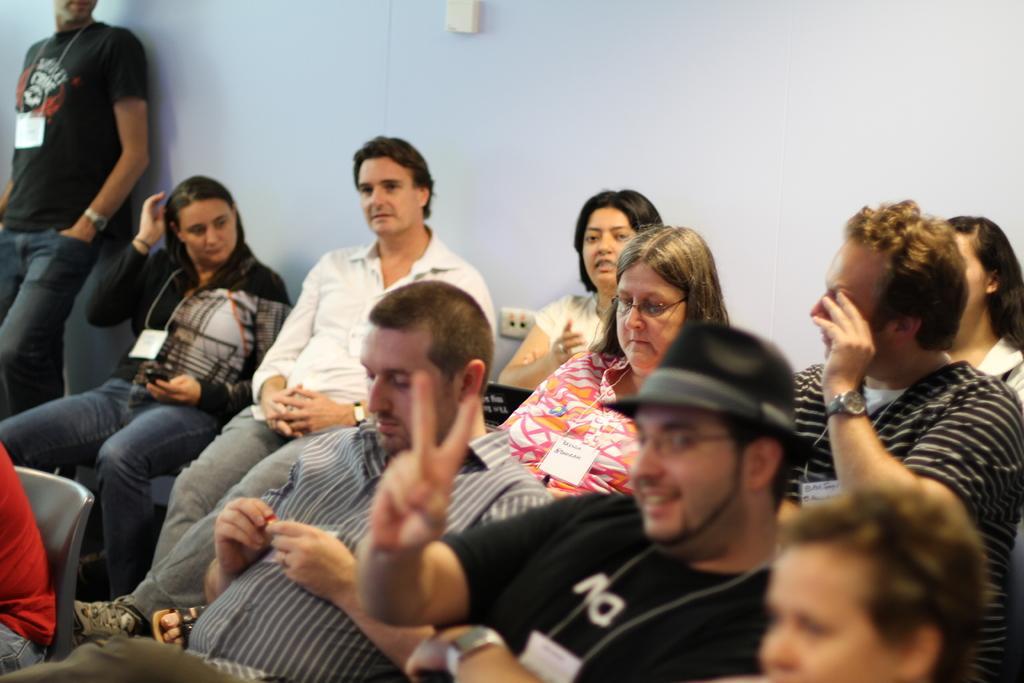How would you summarize this image in a sentence or two? In this image we can see many person sitting on the chairs. On the left side of the image we can see person standing to the wall. In the background there is wall. 